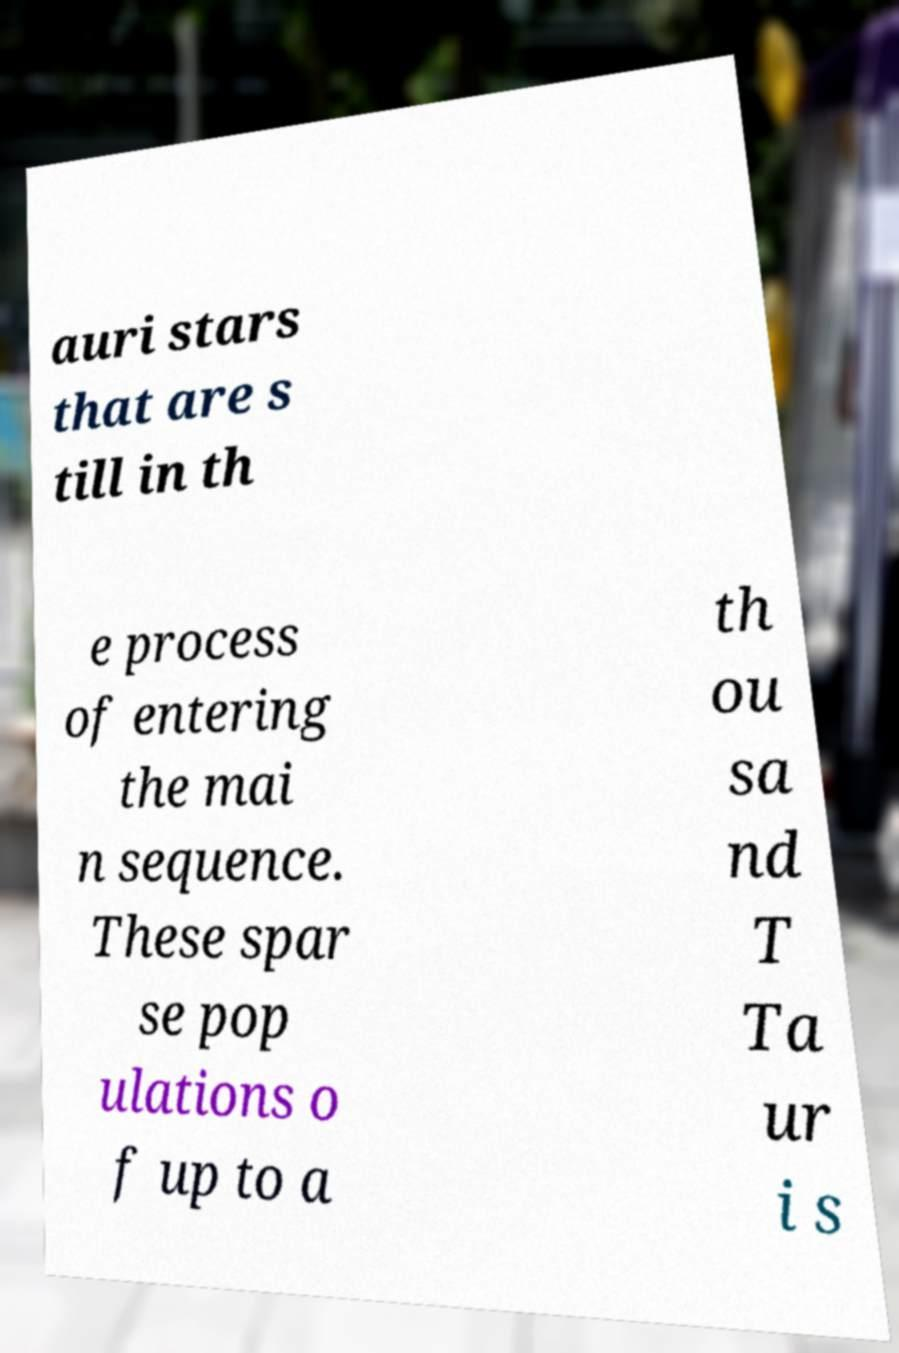Please read and relay the text visible in this image. What does it say? auri stars that are s till in th e process of entering the mai n sequence. These spar se pop ulations o f up to a th ou sa nd T Ta ur i s 